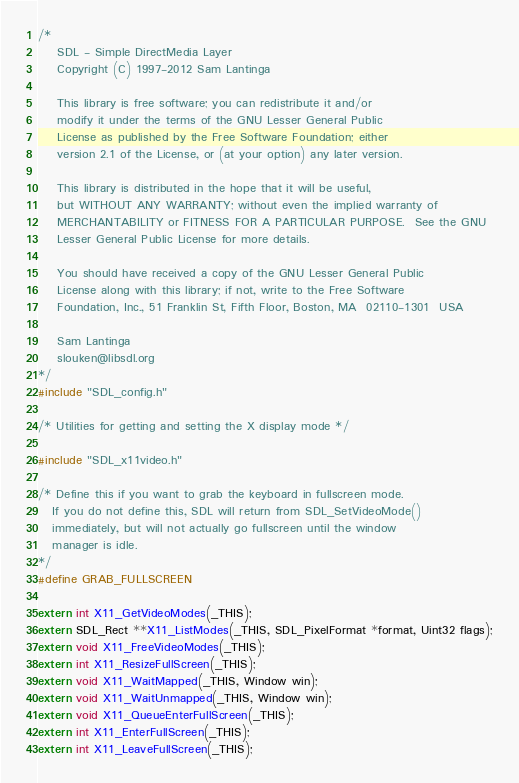<code> <loc_0><loc_0><loc_500><loc_500><_C_>/*
    SDL - Simple DirectMedia Layer
    Copyright (C) 1997-2012 Sam Lantinga

    This library is free software; you can redistribute it and/or
    modify it under the terms of the GNU Lesser General Public
    License as published by the Free Software Foundation; either
    version 2.1 of the License, or (at your option) any later version.

    This library is distributed in the hope that it will be useful,
    but WITHOUT ANY WARRANTY; without even the implied warranty of
    MERCHANTABILITY or FITNESS FOR A PARTICULAR PURPOSE.  See the GNU
    Lesser General Public License for more details.

    You should have received a copy of the GNU Lesser General Public
    License along with this library; if not, write to the Free Software
    Foundation, Inc., 51 Franklin St, Fifth Floor, Boston, MA  02110-1301  USA

    Sam Lantinga
    slouken@libsdl.org
*/
#include "SDL_config.h"

/* Utilities for getting and setting the X display mode */

#include "SDL_x11video.h"

/* Define this if you want to grab the keyboard in fullscreen mode.
   If you do not define this, SDL will return from SDL_SetVideoMode()
   immediately, but will not actually go fullscreen until the window
   manager is idle.
*/
#define GRAB_FULLSCREEN

extern int X11_GetVideoModes(_THIS);
extern SDL_Rect **X11_ListModes(_THIS, SDL_PixelFormat *format, Uint32 flags);
extern void X11_FreeVideoModes(_THIS);
extern int X11_ResizeFullScreen(_THIS);
extern void X11_WaitMapped(_THIS, Window win);
extern void X11_WaitUnmapped(_THIS, Window win);
extern void X11_QueueEnterFullScreen(_THIS);
extern int X11_EnterFullScreen(_THIS);
extern int X11_LeaveFullScreen(_THIS);
</code> 